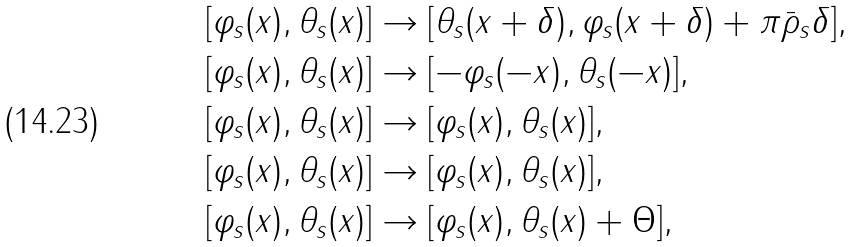Convert formula to latex. <formula><loc_0><loc_0><loc_500><loc_500>& [ \varphi _ { s } ( x ) , \theta _ { s } ( x ) ] \rightarrow [ \theta _ { s } ( x + \delta ) , \varphi _ { s } ( x + \delta ) + \pi \bar { \rho } _ { s } \delta ] , \\ & [ \varphi _ { s } ( x ) , \theta _ { s } ( x ) ] \rightarrow [ - \varphi _ { s } ( - x ) , \theta _ { s } ( - x ) ] , \\ & [ \varphi _ { s } ( x ) , \theta _ { s } ( x ) ] \rightarrow [ \varphi _ { s } ( x ) , \theta _ { s } ( x ) ] , \\ & [ \varphi _ { s } ( x ) , \theta _ { s } ( x ) ] \rightarrow [ \varphi _ { s } ( x ) , \theta _ { s } ( x ) ] , \\ & [ \varphi _ { s } ( x ) , \theta _ { s } ( x ) ] \rightarrow [ \varphi _ { s } ( x ) , \theta _ { s } ( x ) + \Theta ] ,</formula> 